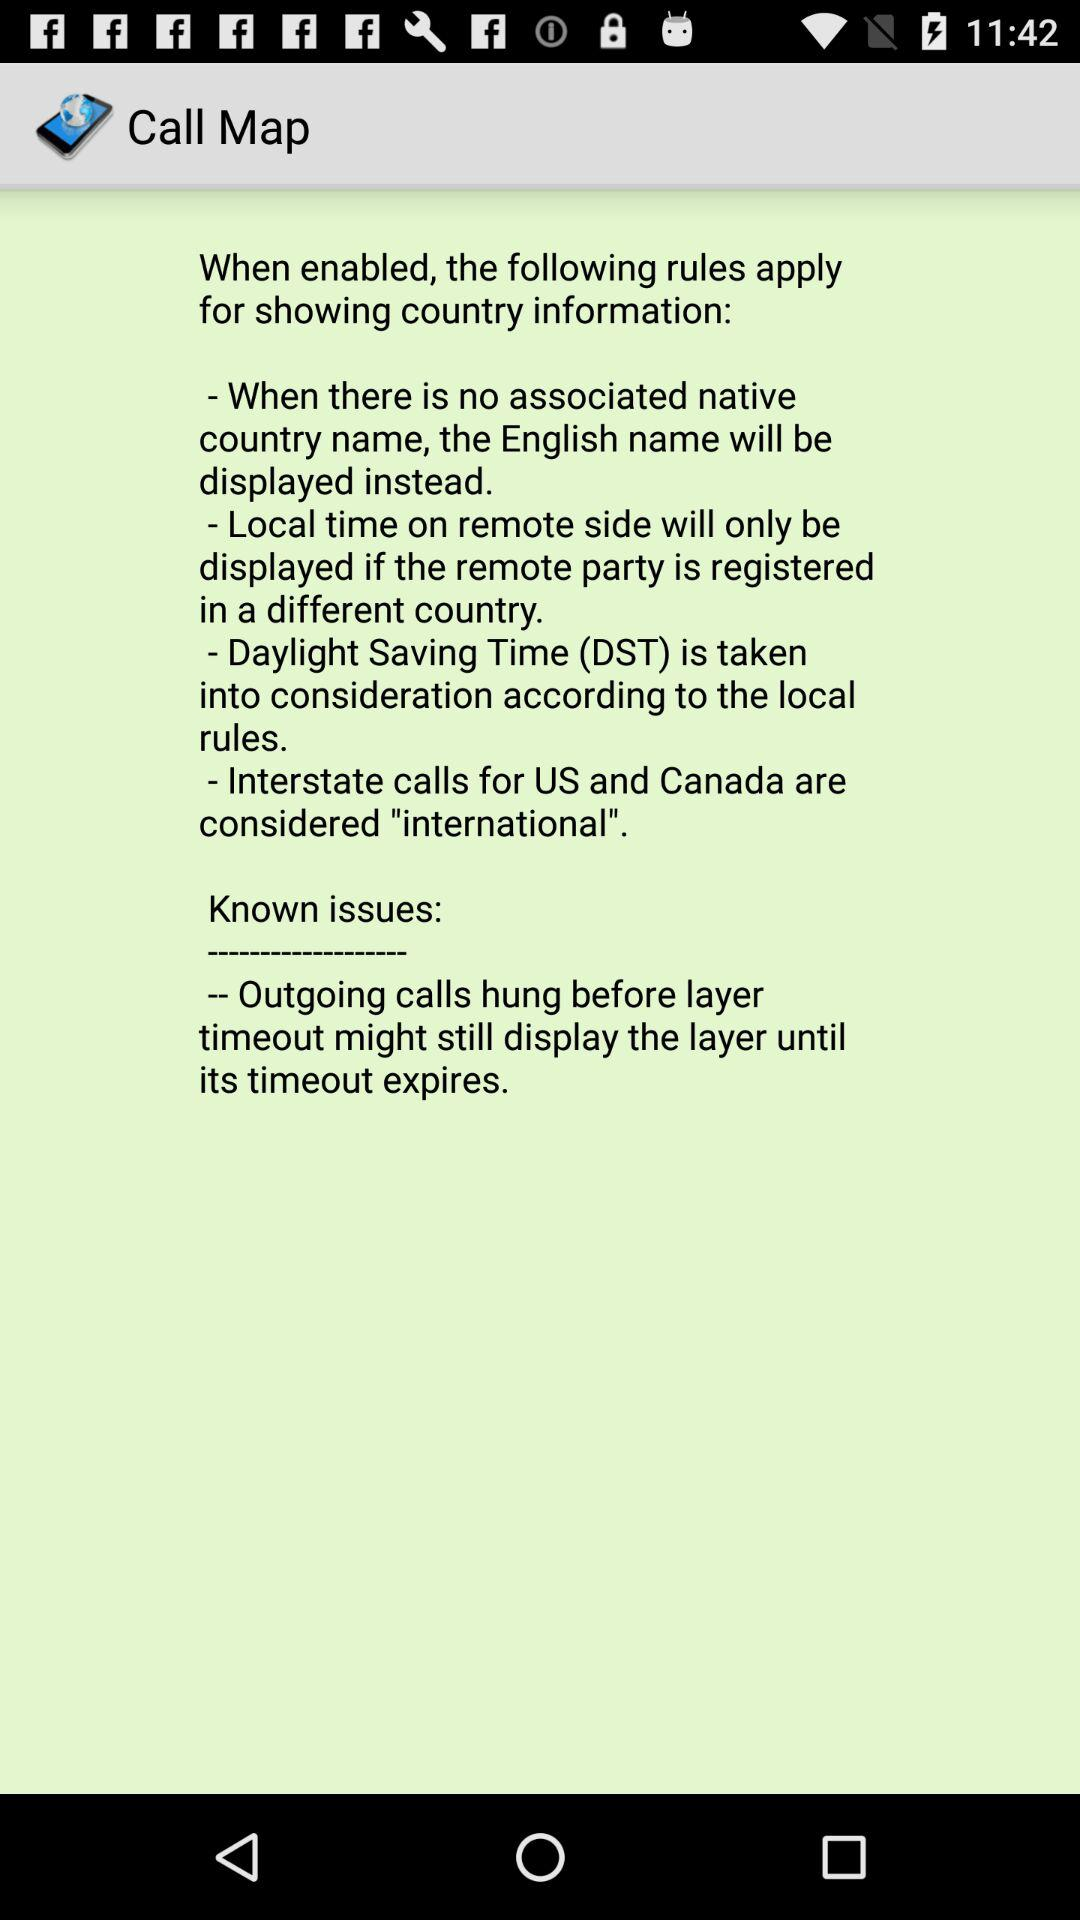What is the name of application? The name of application is "Call Map". 